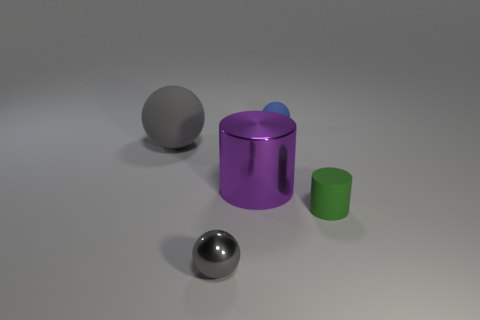There is a matte thing to the left of the tiny gray metallic sphere; what is its color?
Make the answer very short. Gray. Is the number of big cylinders right of the small gray object less than the number of tiny objects that are in front of the large purple thing?
Keep it short and to the point. Yes. How many other things are made of the same material as the large purple thing?
Provide a succinct answer. 1. Do the tiny green cylinder and the large ball have the same material?
Provide a succinct answer. Yes. What number of other things are there of the same size as the gray shiny object?
Your answer should be very brief. 2. There is a rubber thing that is to the right of the small matte thing that is behind the large ball; how big is it?
Your answer should be compact. Small. What color is the small sphere behind the gray ball on the left side of the gray object in front of the rubber cylinder?
Keep it short and to the point. Blue. There is a object that is both on the left side of the large purple shiny object and in front of the large ball; how big is it?
Offer a terse response. Small. What number of other things are the same shape as the purple shiny object?
Ensure brevity in your answer.  1. What number of spheres are small shiny objects or large metal objects?
Provide a short and direct response. 1. 